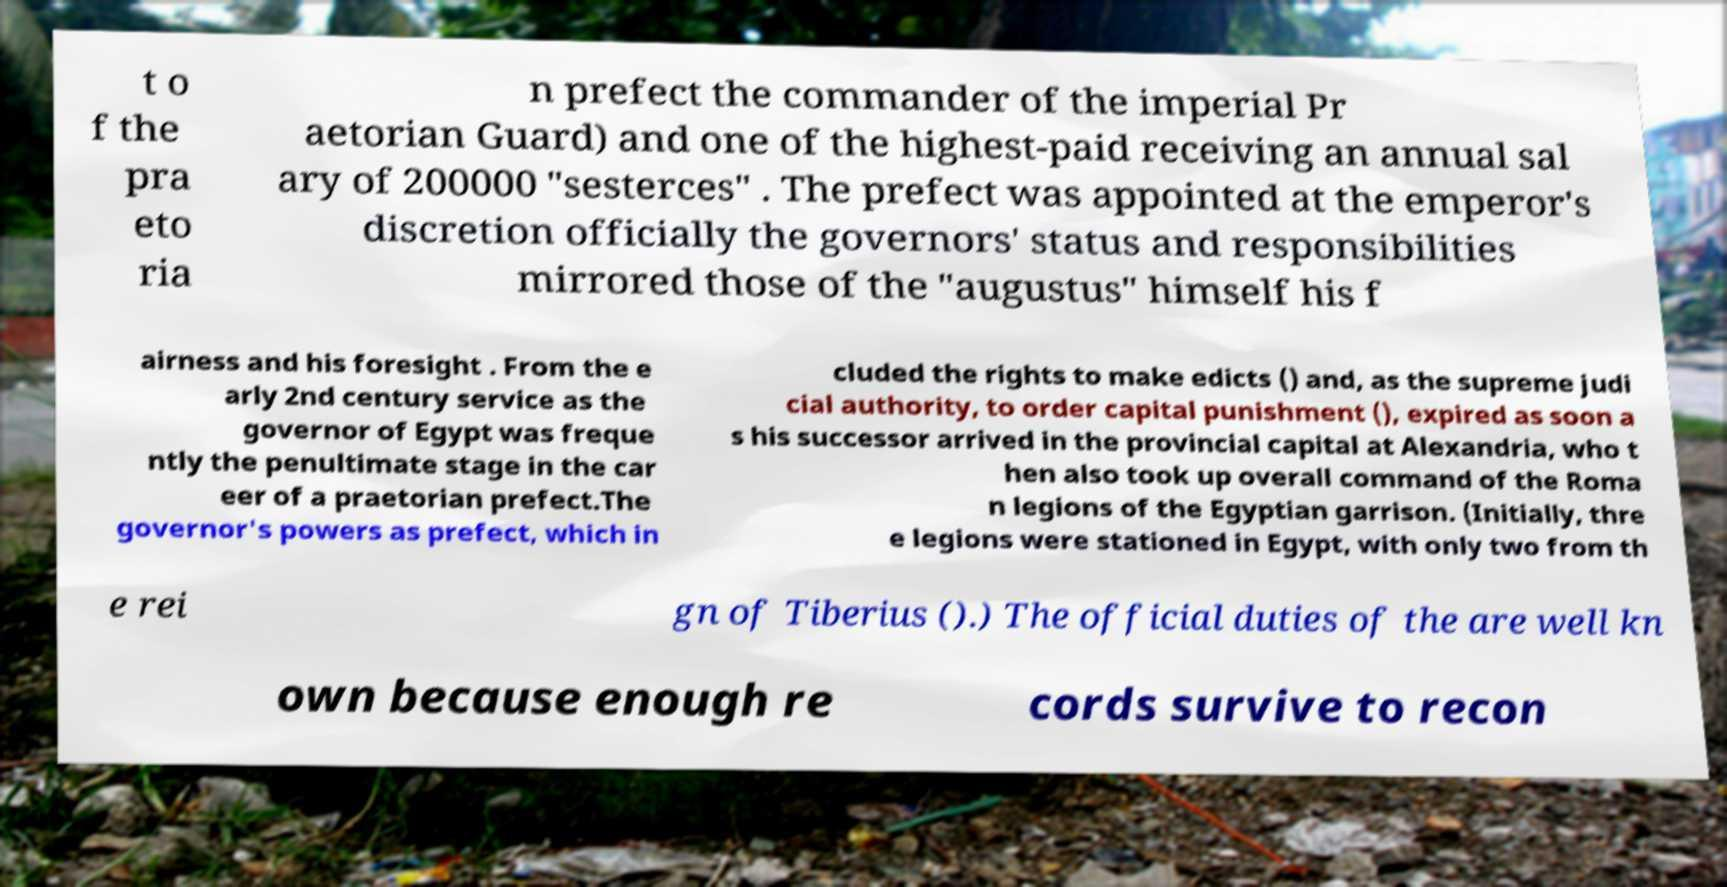For documentation purposes, I need the text within this image transcribed. Could you provide that? t o f the pra eto ria n prefect the commander of the imperial Pr aetorian Guard) and one of the highest-paid receiving an annual sal ary of 200000 "sesterces" . The prefect was appointed at the emperor's discretion officially the governors' status and responsibilities mirrored those of the "augustus" himself his f airness and his foresight . From the e arly 2nd century service as the governor of Egypt was freque ntly the penultimate stage in the car eer of a praetorian prefect.The governor's powers as prefect, which in cluded the rights to make edicts () and, as the supreme judi cial authority, to order capital punishment (), expired as soon a s his successor arrived in the provincial capital at Alexandria, who t hen also took up overall command of the Roma n legions of the Egyptian garrison. (Initially, thre e legions were stationed in Egypt, with only two from th e rei gn of Tiberius ().) The official duties of the are well kn own because enough re cords survive to recon 